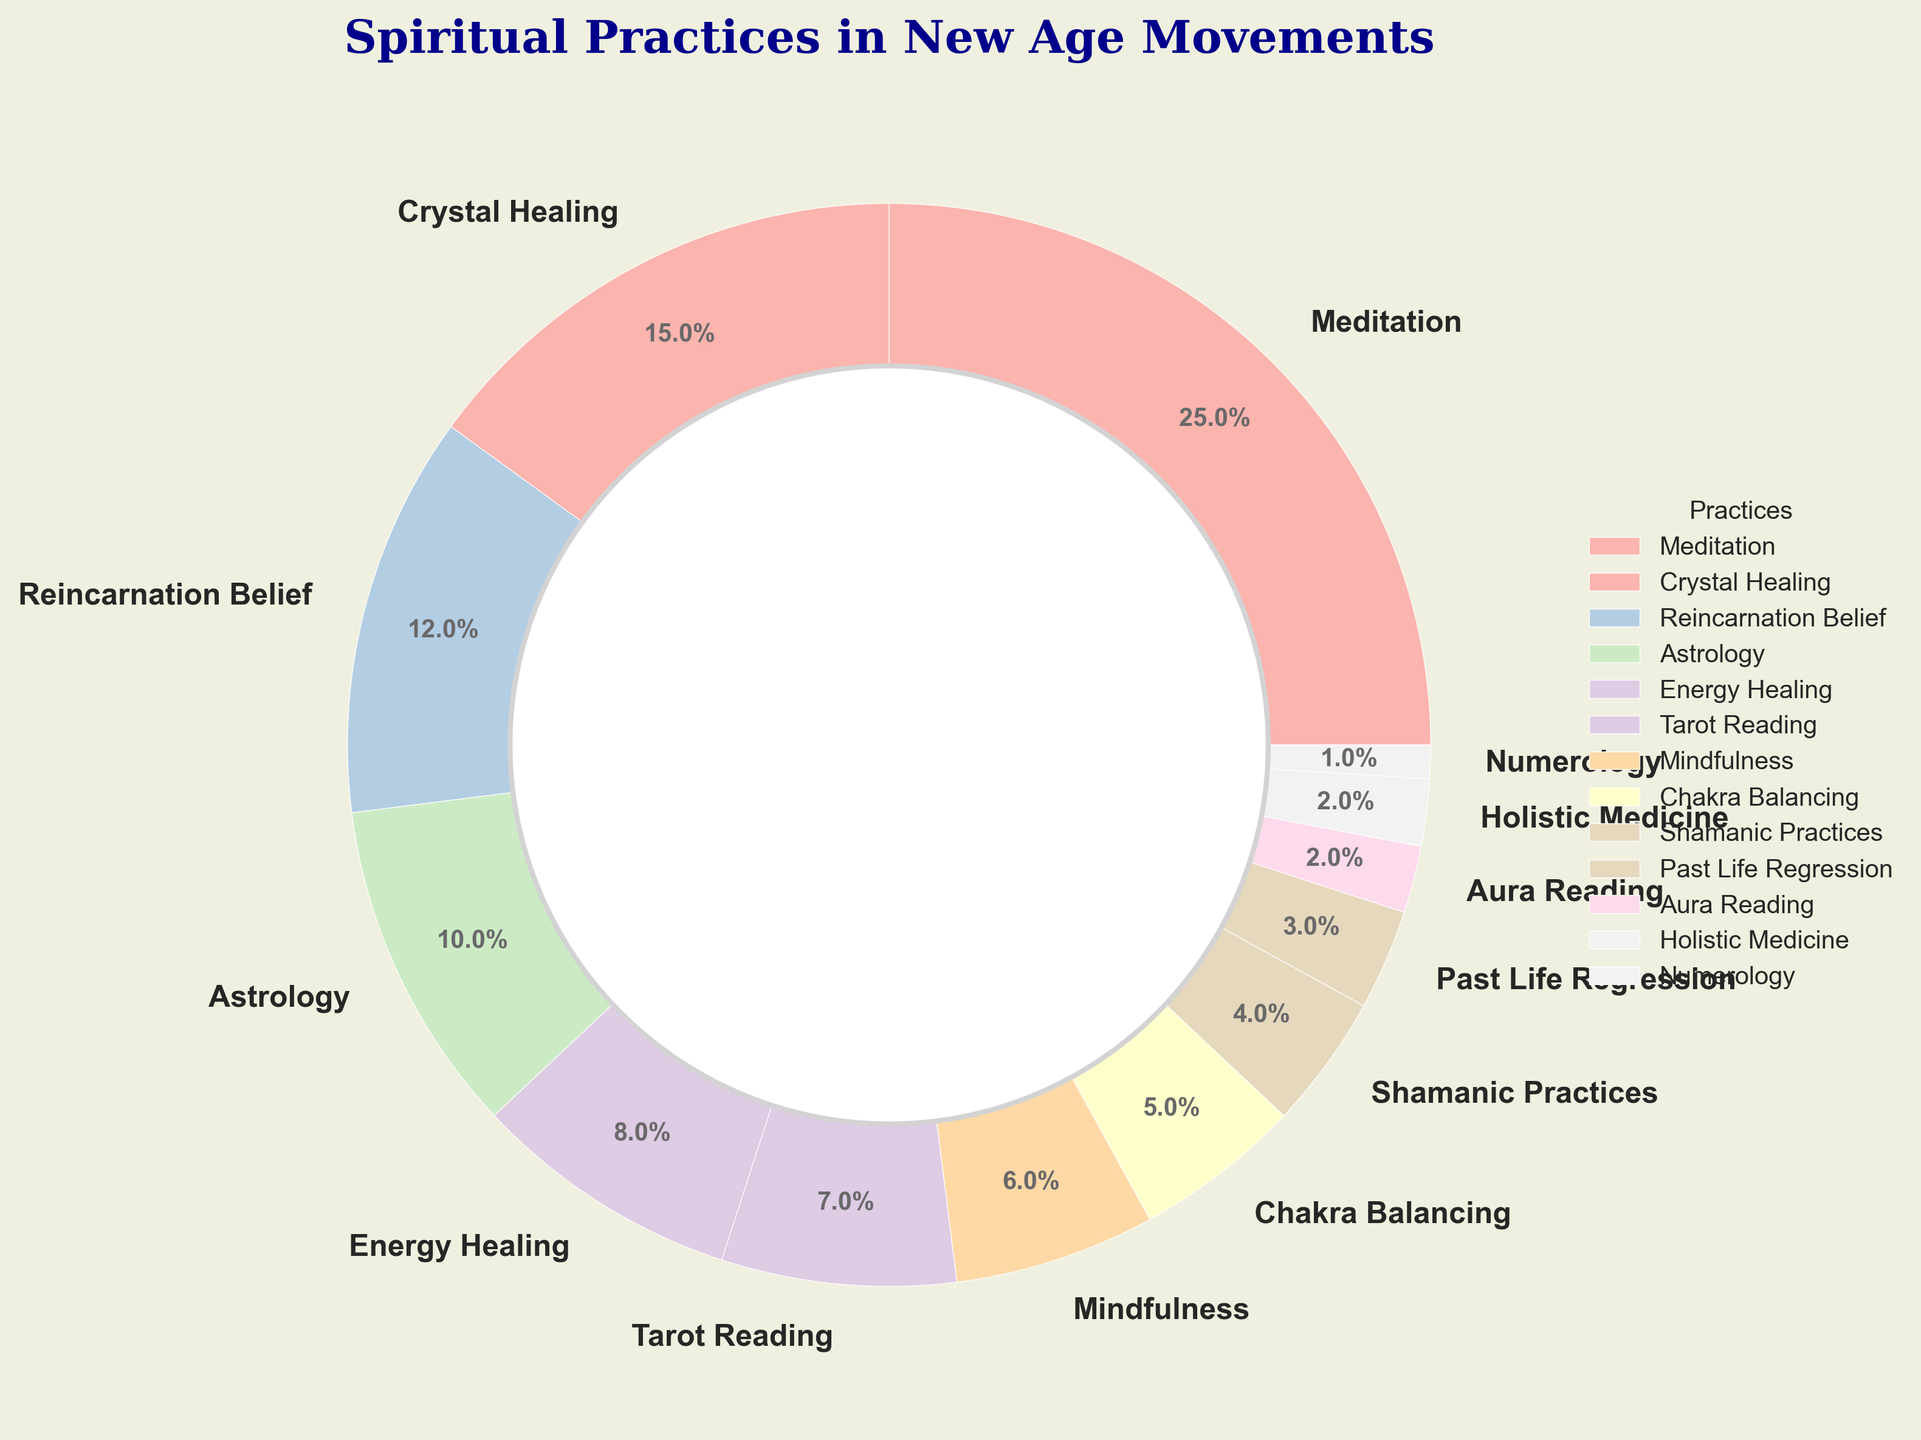What percentage of spiritual practices are devoted to Meditation and Crystal Healing combined? To find the combined percentage, you sum the percentages for Meditation (25%) and Crystal Healing (15%). Therefore, 25% + 15% = 40%.
Answer: 40% Which practice has the smallest representation in the New Age movements, and what is its percentage? The smallest representation is Numerology, with a percentage of 1%. By examining the segments of the pie chart, we can see that Numerology has the smallest segment.
Answer: Numerology, 1% Compare the combined percentage of Chakra Balancing and Shamanic Practices to the percentage of Meditation. Which is higher and by how much? The combined percentage of Chakra Balancing (5%) and Shamanic Practices (4%) is 9%. Meditation stands at 25%. Subtract the combined percentage from the Meditation percentage: 25% - 9% = 16%. Meditation is higher by 16%.
Answer: Meditation, higher by 16% List all practices that constitute less than 5% of the New Age movements according to the chart. According to the chart, Chakra Balancing (5%), Shamanic Practices (4%), Past Life Regression (3%), Aura Reading (2%), Holistic Medicine (2%), and Numerology (1%) all constitute less than 5% each.
Answer: Chakra Balancing, Shamanic Practices, Past Life Regression, Aura Reading, Holistic Medicine, Numerology Compare the visual slice sizes for Energy Healing and Astrological practices. Which is larger and what's their percentage difference? Energy Healing has 8% and Astrology has 10%. To find which is larger, we observe that Astrology has a larger slice. The difference in percentages is 10% - 8% = 2%.
Answer: Astrology, 2% larger How does the combined percentage of Mindfulness and Tarot Reading compare to Crystal Healing? Is one greater, and if so, by what amount? Mindfulness has 6%, and Tarot Reading has 7%. Their combined percentage is 6% + 7% = 13%. Crystal Healing has 15%. The difference is 15% - 13% = 2%. Crystal Healing is greater by 2%.
Answer: Crystal Healing, greater by 2% What is the percentage representation of all practices associated with divination (e.g., Tarot Reading, Astrology, Numerology) combined? Adding the percentages for Tarot Reading (7%), Astrology (10%), and Numerology (1%), the total percentage is 7% + 10% + 1% = 18%.
Answer: 18% Is the percentage of Reincarnation Belief more than double of Past Life Regression? Reincarnation Belief is 12% and Past Life Regression is 3%. Double of Past Life Regression is 3% x 2 = 6%. Since 12% > 6%, Reincarnation Belief is indeed more than double.
Answer: Yes What fraction of the pie chart is dedicated to meditative practices (Meditation and Mindfulness)? Summing Meditation (25%) and Mindfulness (6%) gives us 31%. So, 31% of the pie chart is dedicated to meditative practices.
Answer: 31% If a new category "Spiritual Retreats" were added at 4%, how would the percentages of Chakra Balancing and Shamanic Practices compare to this new category? Chakra Balancing is 5%, which is higher than 4%. Shamanic Practices are 4%, which is equal to the new category. Therefore, Chakra Balancing is higher, and Shamanic Practices are the same.
Answer: Chakra Balancing is higher, Shamanic Practices are equal 